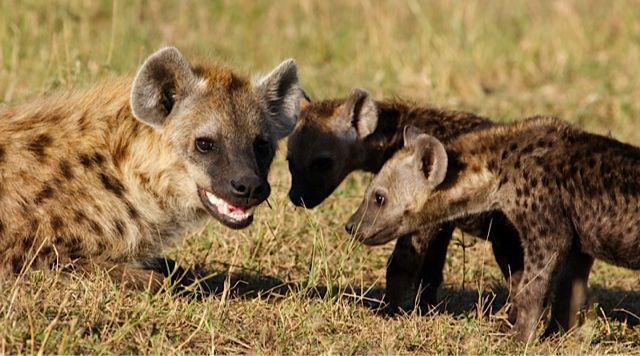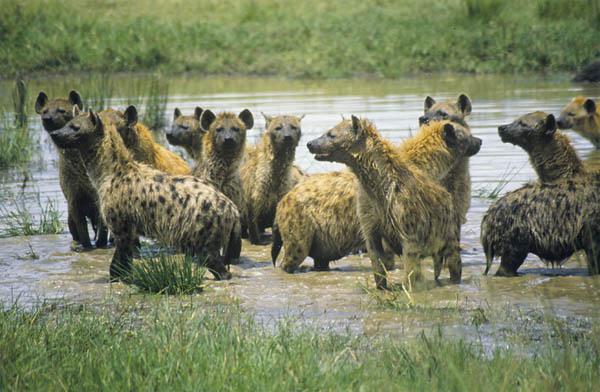The first image is the image on the left, the second image is the image on the right. Examine the images to the left and right. Is the description "One of the images contains birds along side the animals." accurate? Answer yes or no. No. The first image is the image on the left, the second image is the image on the right. Assess this claim about the two images: "Left image includes zebra in an image with hyena.". Correct or not? Answer yes or no. No. 